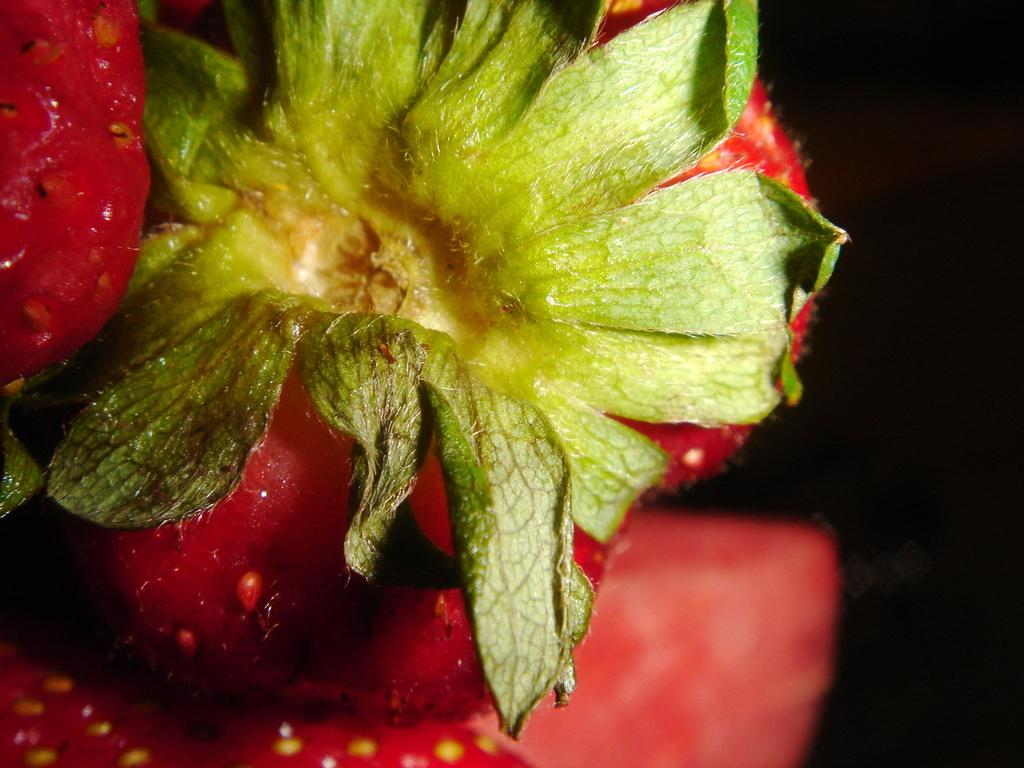What type of fruit is on the left side of the image? There are strawberries on the left side of the image. What part of the strawberries is still attached? The strawberries have leaves. What color is the background of the image? The background of the image is black. Can you tell me how many volcanoes are visible in the image? There are no volcanoes present in the image; it features strawberries with leaves against a black background. How many sisters are sitting in the lunchroom in the image? There is no lunchroom or sisters present in the image. 